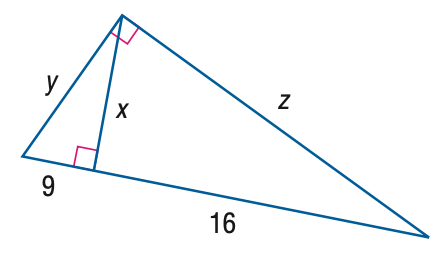Answer the mathemtical geometry problem and directly provide the correct option letter.
Question: Find y.
Choices: A: 15 B: 16 C: 18 D: 20 A 